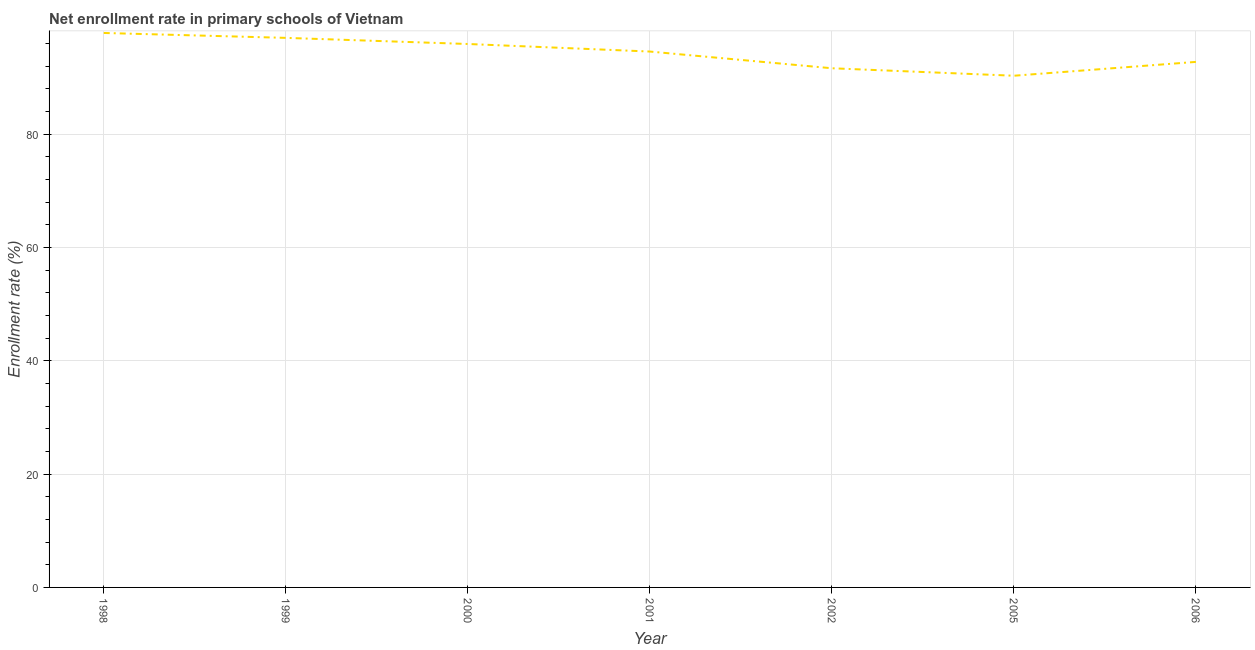What is the net enrollment rate in primary schools in 2005?
Your response must be concise. 90.34. Across all years, what is the maximum net enrollment rate in primary schools?
Make the answer very short. 97.89. Across all years, what is the minimum net enrollment rate in primary schools?
Your response must be concise. 90.34. What is the sum of the net enrollment rate in primary schools?
Provide a succinct answer. 660.25. What is the difference between the net enrollment rate in primary schools in 1998 and 2000?
Your answer should be very brief. 1.95. What is the average net enrollment rate in primary schools per year?
Your response must be concise. 94.32. What is the median net enrollment rate in primary schools?
Your answer should be compact. 94.61. In how many years, is the net enrollment rate in primary schools greater than 88 %?
Provide a succinct answer. 7. Do a majority of the years between 2001 and 1999 (inclusive) have net enrollment rate in primary schools greater than 8 %?
Provide a succinct answer. No. What is the ratio of the net enrollment rate in primary schools in 2000 to that in 2005?
Give a very brief answer. 1.06. Is the net enrollment rate in primary schools in 2002 less than that in 2005?
Provide a short and direct response. No. What is the difference between the highest and the second highest net enrollment rate in primary schools?
Offer a very short reply. 0.87. What is the difference between the highest and the lowest net enrollment rate in primary schools?
Provide a short and direct response. 7.55. Does the net enrollment rate in primary schools monotonically increase over the years?
Offer a very short reply. No. Does the graph contain grids?
Ensure brevity in your answer.  Yes. What is the title of the graph?
Your answer should be very brief. Net enrollment rate in primary schools of Vietnam. What is the label or title of the X-axis?
Offer a very short reply. Year. What is the label or title of the Y-axis?
Your response must be concise. Enrollment rate (%). What is the Enrollment rate (%) of 1998?
Your answer should be very brief. 97.89. What is the Enrollment rate (%) of 1999?
Provide a succinct answer. 97.02. What is the Enrollment rate (%) of 2000?
Provide a short and direct response. 95.94. What is the Enrollment rate (%) in 2001?
Your answer should be very brief. 94.61. What is the Enrollment rate (%) of 2002?
Keep it short and to the point. 91.66. What is the Enrollment rate (%) in 2005?
Offer a terse response. 90.34. What is the Enrollment rate (%) in 2006?
Your response must be concise. 92.78. What is the difference between the Enrollment rate (%) in 1998 and 1999?
Your answer should be very brief. 0.87. What is the difference between the Enrollment rate (%) in 1998 and 2000?
Your answer should be very brief. 1.95. What is the difference between the Enrollment rate (%) in 1998 and 2001?
Provide a short and direct response. 3.28. What is the difference between the Enrollment rate (%) in 1998 and 2002?
Your answer should be very brief. 6.23. What is the difference between the Enrollment rate (%) in 1998 and 2005?
Make the answer very short. 7.55. What is the difference between the Enrollment rate (%) in 1998 and 2006?
Your answer should be very brief. 5.11. What is the difference between the Enrollment rate (%) in 1999 and 2000?
Keep it short and to the point. 1.08. What is the difference between the Enrollment rate (%) in 1999 and 2001?
Offer a terse response. 2.41. What is the difference between the Enrollment rate (%) in 1999 and 2002?
Make the answer very short. 5.37. What is the difference between the Enrollment rate (%) in 1999 and 2005?
Your response must be concise. 6.69. What is the difference between the Enrollment rate (%) in 1999 and 2006?
Your answer should be very brief. 4.24. What is the difference between the Enrollment rate (%) in 2000 and 2001?
Provide a succinct answer. 1.33. What is the difference between the Enrollment rate (%) in 2000 and 2002?
Offer a very short reply. 4.29. What is the difference between the Enrollment rate (%) in 2000 and 2005?
Ensure brevity in your answer.  5.6. What is the difference between the Enrollment rate (%) in 2000 and 2006?
Keep it short and to the point. 3.16. What is the difference between the Enrollment rate (%) in 2001 and 2002?
Offer a very short reply. 2.95. What is the difference between the Enrollment rate (%) in 2001 and 2005?
Your response must be concise. 4.27. What is the difference between the Enrollment rate (%) in 2001 and 2006?
Offer a terse response. 1.83. What is the difference between the Enrollment rate (%) in 2002 and 2005?
Offer a terse response. 1.32. What is the difference between the Enrollment rate (%) in 2002 and 2006?
Make the answer very short. -1.12. What is the difference between the Enrollment rate (%) in 2005 and 2006?
Your answer should be compact. -2.44. What is the ratio of the Enrollment rate (%) in 1998 to that in 2000?
Keep it short and to the point. 1.02. What is the ratio of the Enrollment rate (%) in 1998 to that in 2001?
Keep it short and to the point. 1.03. What is the ratio of the Enrollment rate (%) in 1998 to that in 2002?
Keep it short and to the point. 1.07. What is the ratio of the Enrollment rate (%) in 1998 to that in 2005?
Make the answer very short. 1.08. What is the ratio of the Enrollment rate (%) in 1998 to that in 2006?
Ensure brevity in your answer.  1.05. What is the ratio of the Enrollment rate (%) in 1999 to that in 2000?
Make the answer very short. 1.01. What is the ratio of the Enrollment rate (%) in 1999 to that in 2002?
Your answer should be very brief. 1.06. What is the ratio of the Enrollment rate (%) in 1999 to that in 2005?
Give a very brief answer. 1.07. What is the ratio of the Enrollment rate (%) in 1999 to that in 2006?
Offer a very short reply. 1.05. What is the ratio of the Enrollment rate (%) in 2000 to that in 2001?
Provide a succinct answer. 1.01. What is the ratio of the Enrollment rate (%) in 2000 to that in 2002?
Offer a very short reply. 1.05. What is the ratio of the Enrollment rate (%) in 2000 to that in 2005?
Ensure brevity in your answer.  1.06. What is the ratio of the Enrollment rate (%) in 2000 to that in 2006?
Your answer should be very brief. 1.03. What is the ratio of the Enrollment rate (%) in 2001 to that in 2002?
Provide a short and direct response. 1.03. What is the ratio of the Enrollment rate (%) in 2001 to that in 2005?
Your answer should be very brief. 1.05. What is the ratio of the Enrollment rate (%) in 2002 to that in 2005?
Offer a terse response. 1.01. What is the ratio of the Enrollment rate (%) in 2002 to that in 2006?
Offer a very short reply. 0.99. What is the ratio of the Enrollment rate (%) in 2005 to that in 2006?
Your answer should be compact. 0.97. 